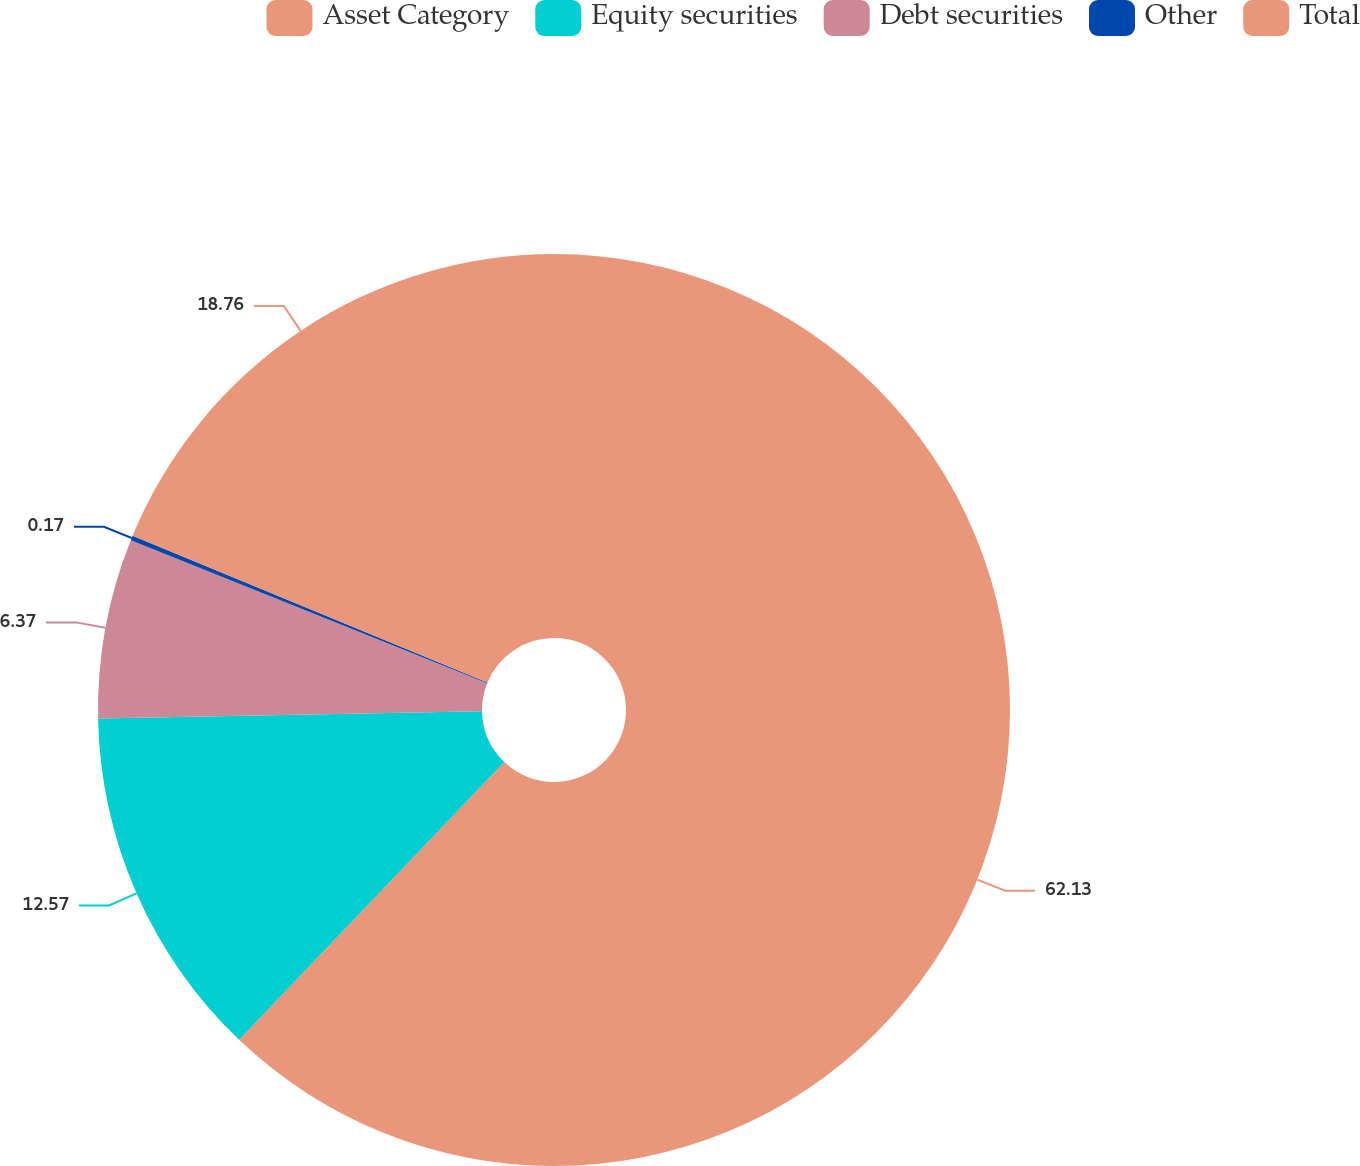Convert chart to OTSL. <chart><loc_0><loc_0><loc_500><loc_500><pie_chart><fcel>Asset Category<fcel>Equity securities<fcel>Debt securities<fcel>Other<fcel>Total<nl><fcel>62.13%<fcel>12.57%<fcel>6.37%<fcel>0.17%<fcel>18.76%<nl></chart> 